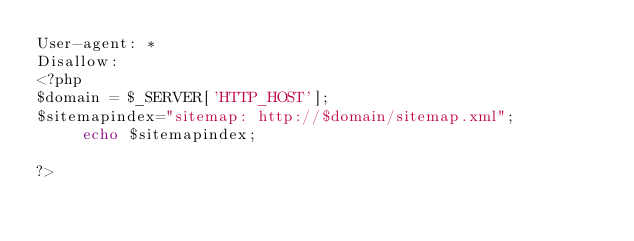<code> <loc_0><loc_0><loc_500><loc_500><_PHP_>User-agent: *
Disallow:
<?php
$domain = $_SERVER['HTTP_HOST'];
$sitemapindex="sitemap: http://$domain/sitemap.xml";
	 echo $sitemapindex;

?>
</code> 